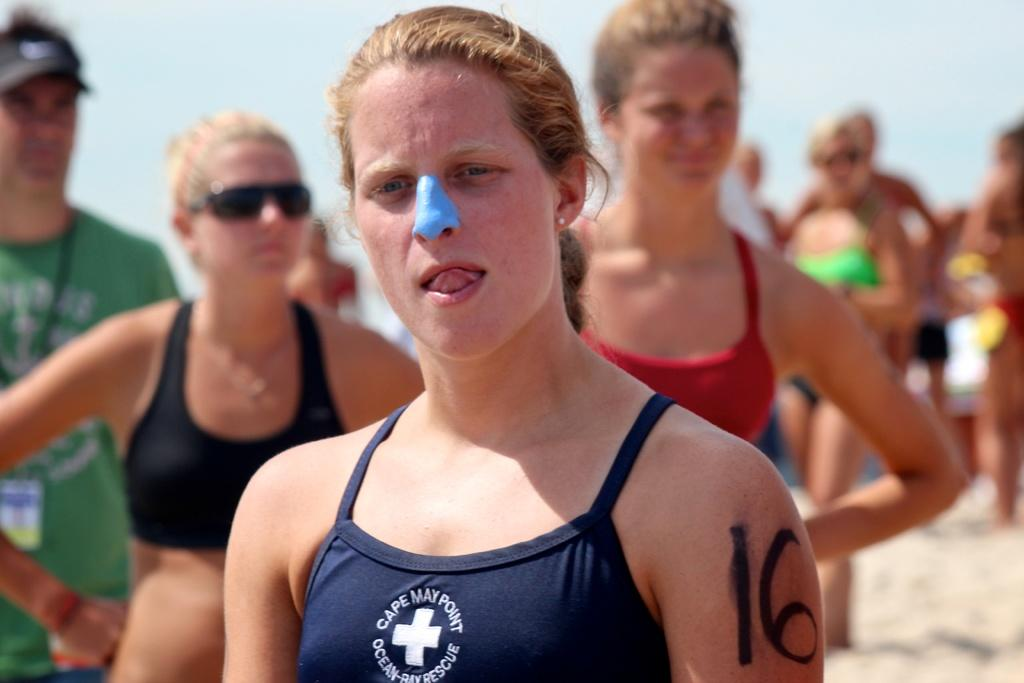<image>
Write a terse but informative summary of the picture. A woman with a blue substance on her nose wears a Cape May Point bathing suit. 